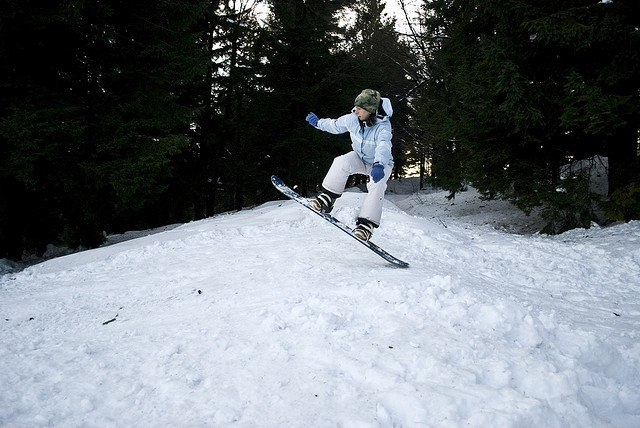Describe the objects in this image and their specific colors. I can see people in black, lightgray, and darkgray tones and snowboard in black, lightgray, gray, and darkgray tones in this image. 